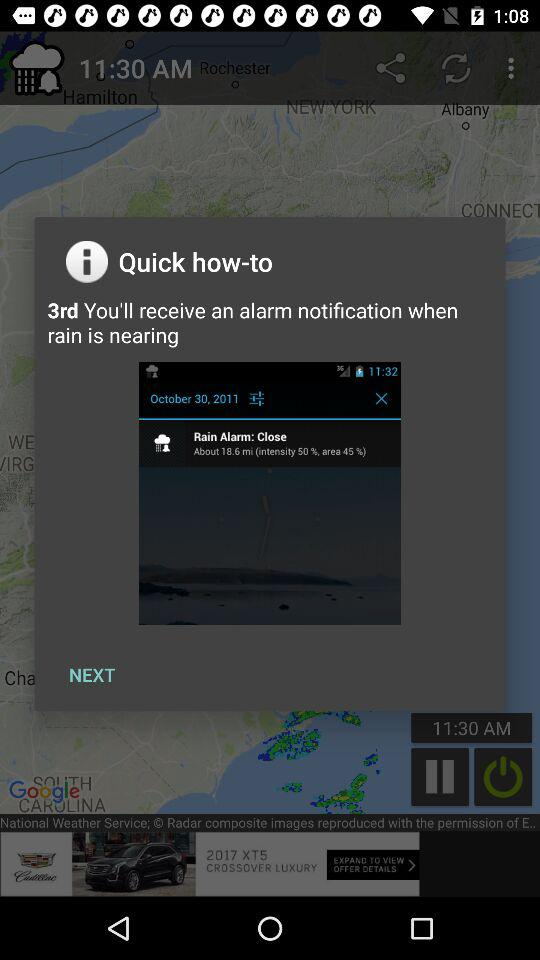When will I receive the notification? You will receive the notification when rain is nearing. 